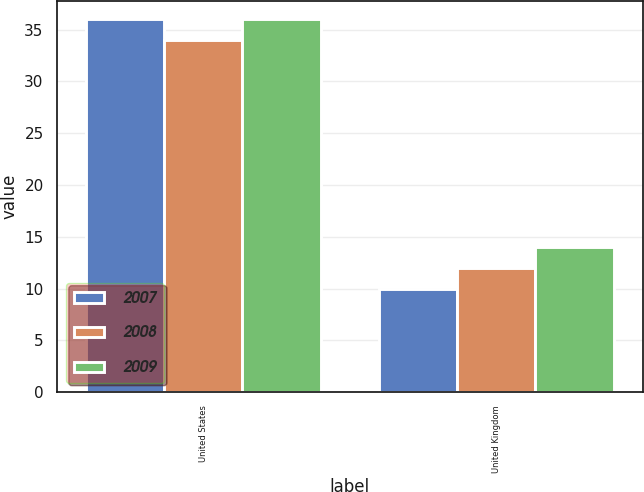<chart> <loc_0><loc_0><loc_500><loc_500><stacked_bar_chart><ecel><fcel>United States<fcel>United Kingdom<nl><fcel>2007<fcel>36<fcel>10<nl><fcel>2008<fcel>34<fcel>12<nl><fcel>2009<fcel>36<fcel>14<nl></chart> 